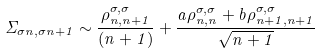<formula> <loc_0><loc_0><loc_500><loc_500>\Sigma _ { \sigma n , \sigma n + 1 } \sim \frac { \rho ^ { \sigma , \sigma } _ { n , n + 1 } } { ( n + 1 ) } + \frac { a \rho ^ { \sigma , \sigma } _ { n , n } + b \rho ^ { \sigma , \sigma } _ { n + 1 , n + 1 } } { \sqrt { n + 1 } }</formula> 